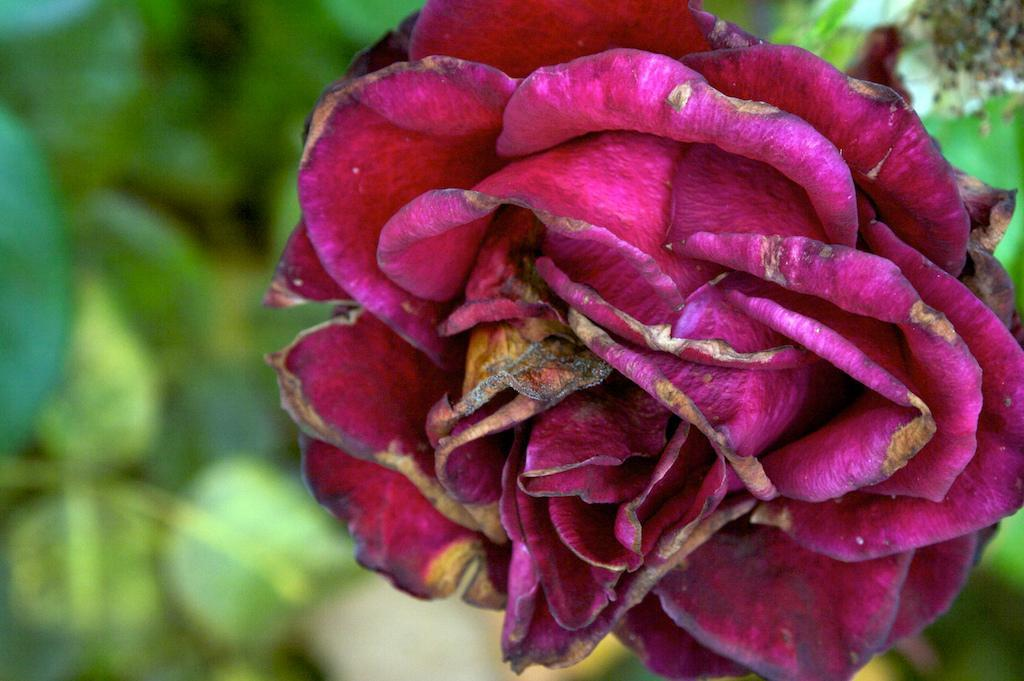What is the main subject of the image? There is a flower in the image. What color is the flower? The flower is pink in color. What can be seen in the background of the image? There are green leaves in the background of the image. Is there a farmer tending to the flower in the image? There is no farmer present in the image. Can you see a monkey climbing the flower in the image? There is no monkey present in the image. 